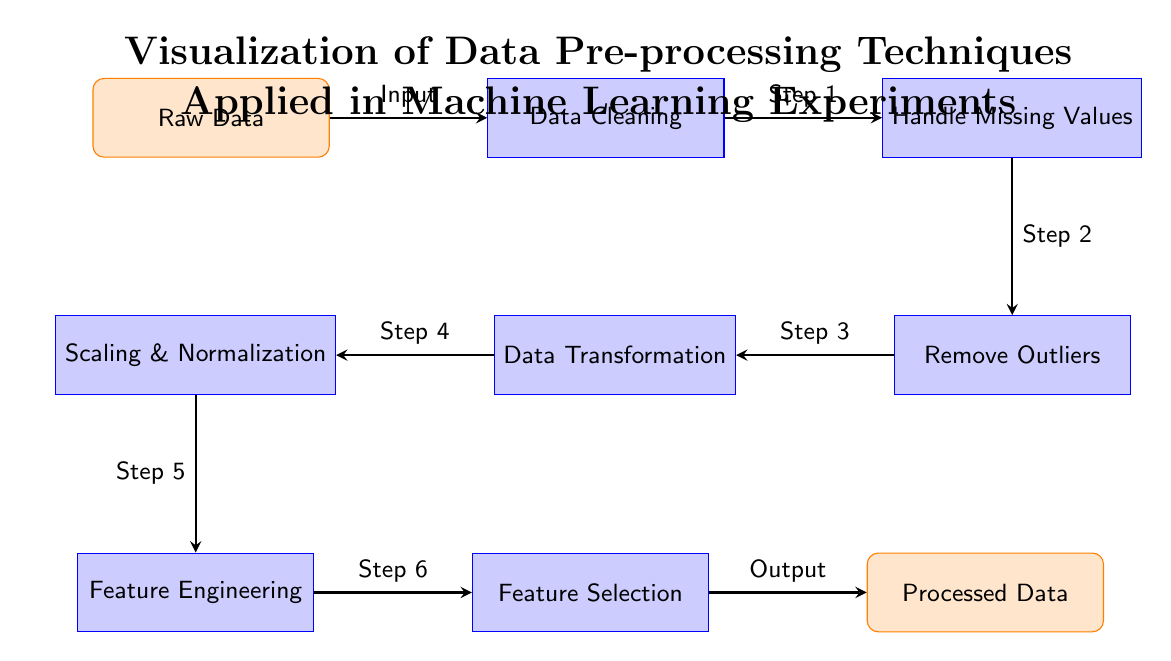What is the first step in the diagram? The first step in the diagram is depicted as transitioning from "Raw Data" to "Data Cleaning". Therefore, the first step involves cleaning the data.
Answer: Data Cleaning How many processes are involved in the data pre-processing? By counting the processes, we find that there are five processes represented by the rectangular nodes: Data Cleaning, Handle Missing Values, Remove Outliers, Data Transformation, Scaling & Normalization, Feature Engineering, and Feature Selection. Thus, adding these, we get a total of six processes involved in the diagram.
Answer: Six What is the output of the pre-processing techniques? The final output node of the pre-processing techniques is labeled "Processed Data", which represents the end result after the data has been cleaned and transformed through various techniques.
Answer: Processed Data Which step comes after handling missing values? The step that follows "Handle Missing Values" is "Remove Outliers" as indicated by the arrow pointing to that process, showing the progression from missing values handling to outlier removal.
Answer: Remove Outliers What technique is applied after Scaling & Normalization? After "Scaling & Normalization", the subsequent technique is "Feature Engineering" based on the flow of the diagram, which demonstrates the sequence of data pre-processing methods.
Answer: Feature Engineering What is the relationship between Data Transformation and Scaling & Normalization? The relationship is that "Data Transformation" precedes "Scaling & Normalization", indicating that data is first transformed before applying scaling and normalization techniques in the pre-processing pipeline.
Answer: Preceding step How many nodes represent data inputs or outputs? There are two nodes designated as data inputs or outputs: "Raw Data" as input and "Processed Data" as output. Thus, we count these for the input and output representation in the diagram.
Answer: Two What is the purpose of Feature Selection in this process? The purpose of "Feature Selection" is to identify and choose relevant features from the data after prior processing has been completed, ensuring that only the most informative features are used for machine learning modeling.
Answer: Identify relevant features Which process occurs directly after Remove Outliers? The process that occurs directly after "Remove Outliers" is "Data Transformation", as indicated by the arrow leading from outlier removal to data transformation, signifying that the process follows logically.
Answer: Data Transformation 